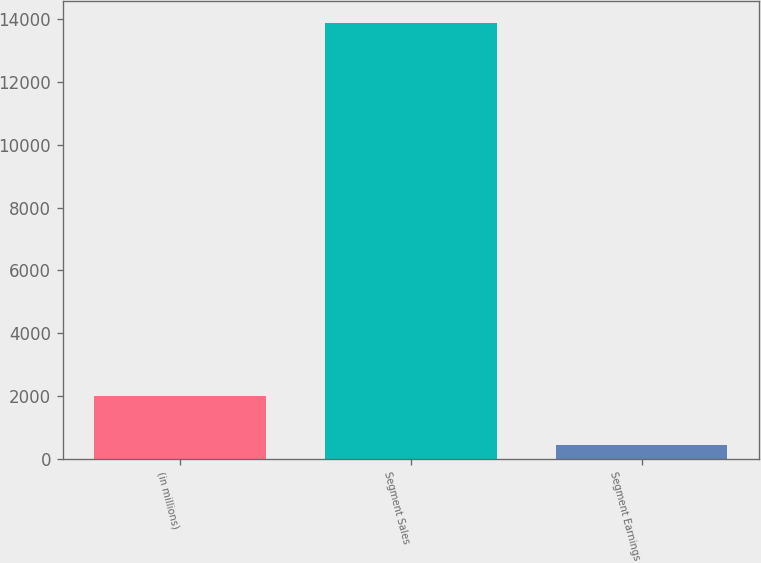Convert chart to OTSL. <chart><loc_0><loc_0><loc_500><loc_500><bar_chart><fcel>(in millions)<fcel>Segment Sales<fcel>Segment Earnings<nl><fcel>2014<fcel>13887<fcel>428<nl></chart> 